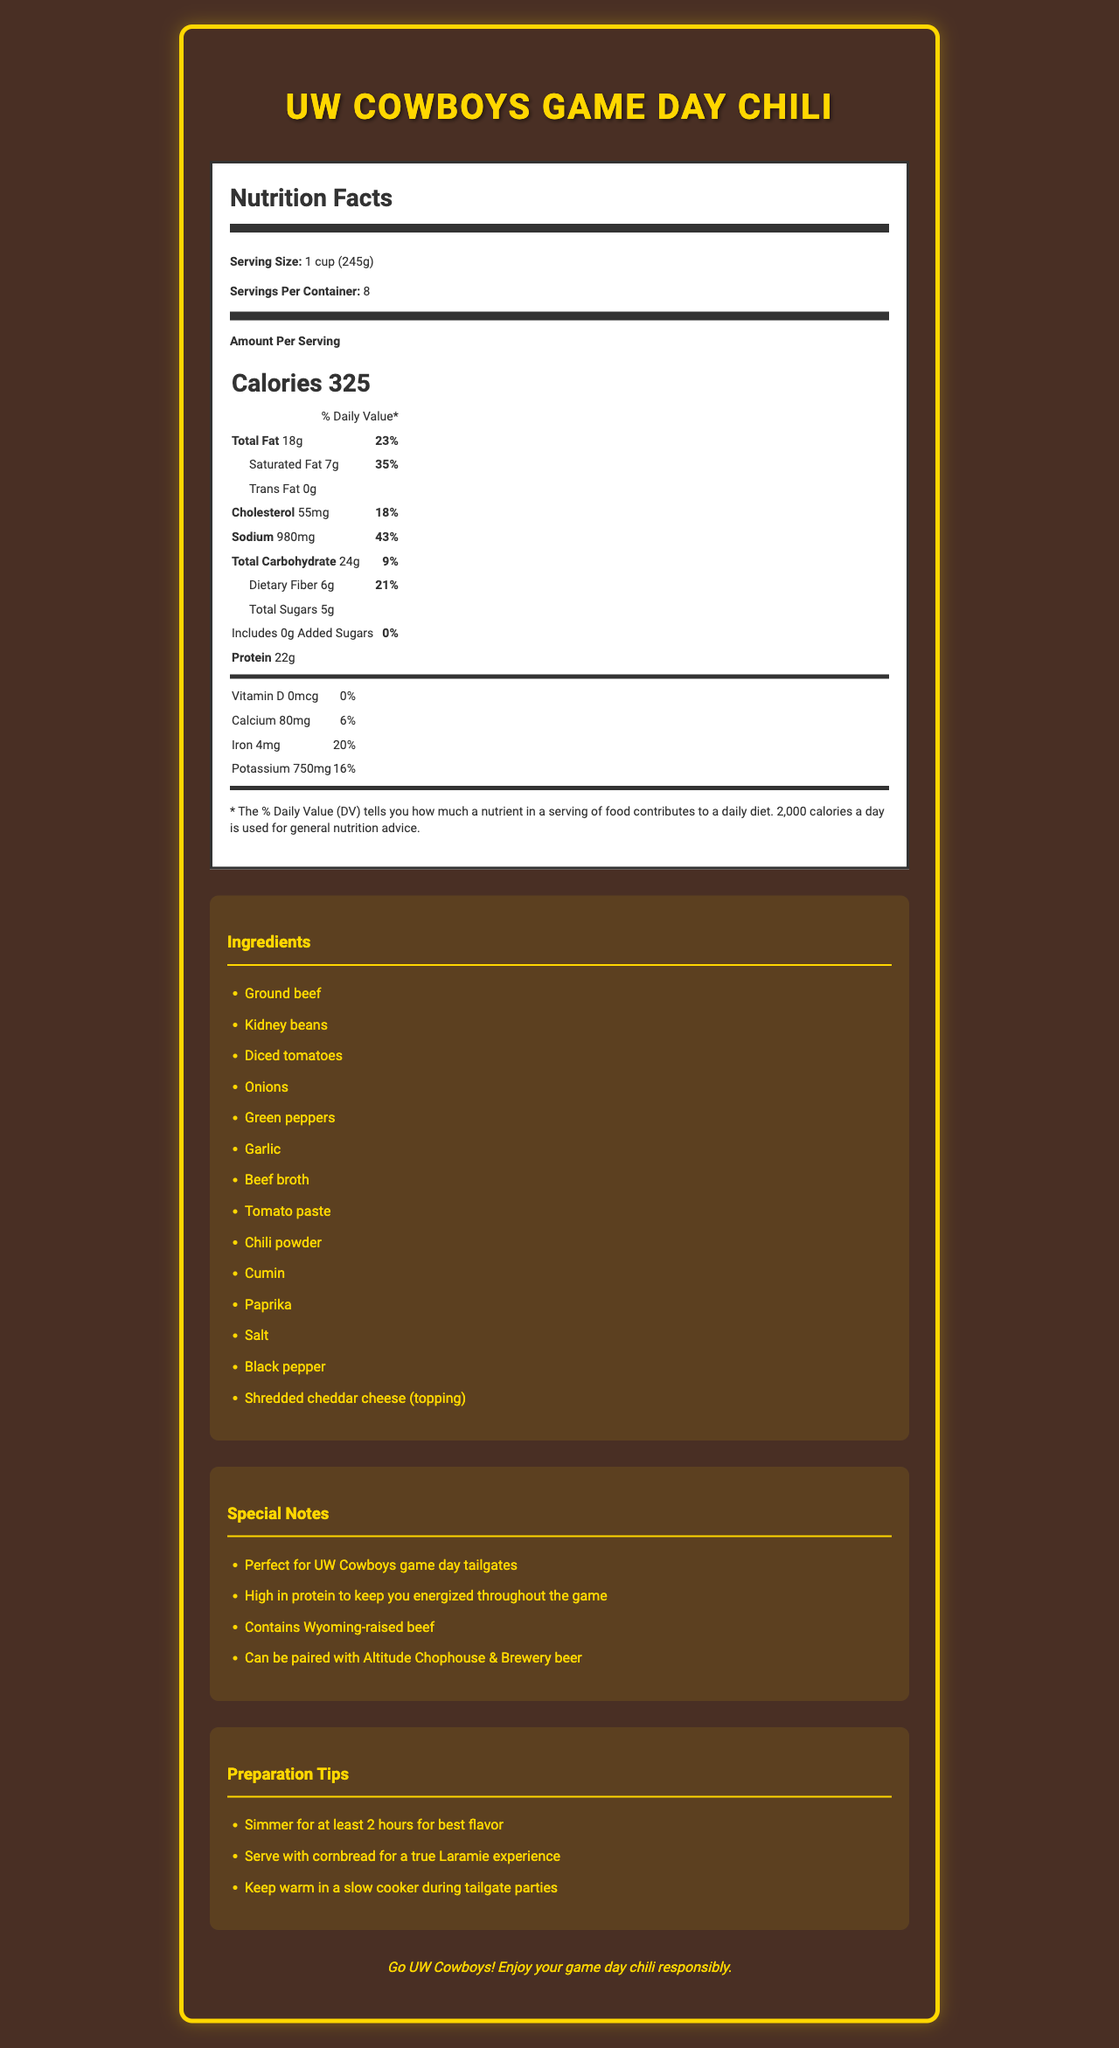what is the serving size for the chili? The serving size is specified right at the top of the nutrition label as "1 cup (245g)".
Answer: 1 cup (245g) how many calories are in a serving of this chili? The calories per serving are mentioned in bold as "Calories 325" on the nutrition label.
Answer: 325 what is the daily value percentage of potassium in a serving? This information is found in the table under potassium, which mentions "16%".
Answer: 16% how much protein is in each serving? The amount of protein per serving is listed as "22g" under the nutrition facts table.
Answer: 22g what allergen is listed for this chili recipe? The allergen information states "Milk" as the only listed allergen.
Answer: Milk what is the percentage of daily value for saturated fat in this chili? The daily value for saturated fat is mentioned as "35%" next to the saturated fat amount in the nutrition information.
Answer: 35% which of the following vitamins or minerals has the highest daily value percentage in the chili? A. Vitamin D B. Calcium C. Iron D. Potassium Iron has the highest daily value percentage at 20%, as shown in the nutrition facts.
Answer: C. Iron what type of beef is used in the chili according to the special notes? A. Grass-fed beef B. Wyoming-raised beef C. Organic beef D. Imported beef The special notes mention "Contains Wyoming-raised beef."
Answer: B. Wyoming-raised beef is the chili high in protein? The document highlights that the chili is "High in protein to keep you energized throughout the game," and it contains 22g of protein per serving.
Answer: Yes describe the main idea of the document. The document is structured to present comprehensive nutritional information and additional relevant details such as ingredients, special notes, and preparation tips to enhance the tailgate experience.
Answer: The document provides a detailed nutrition facts label for a UW Cowboys game day chili recipe, listing serving size, calorie content, macronutrients, vitamins, and minerals. Additionally, it includes a list of ingredients, special notes emphasizing the use of Wyoming-raised beef and game day suitability, and preparation tips for optimal flavor and experience. what is the cholesterol content per serving of the chili? The cholesterol content is listed as "55mg" on the nutrition facts label.
Answer: 55mg how many servings does the container of chili provide? The document specifies that there are 8 servings per container.
Answer: 8 what preparation tips are given for serving the chili at a tailgate party? The preparation tips section provides these three specific tips to enhance the chili's flavor and experience at a tailgate party.
Answer: Simmer for at least 2 hours for best flavor, Serve with cornbread for a true Laramie experience, Keep warm in a slow cooker during tailgate parties what is the ingredient listed as a topping for the chili? The ingredient list includes "Shredded cheddar cheese (topping)" as the topping for the chili.
Answer: Shredded cheddar cheese which nutrient does not have any added content in the chili? A. Sugar B. Sodium C. Potassium D. Protein The nutrition information specifies that the chili includes no added sugars.
Answer: A. Sugar what percentage of daily value for calcium does the chili provide? The nutrition facts indicate that the chili provides 6% of the daily value for calcium.
Answer: 6% what is the total carbohydrate content per serving? The total carbohydrate content is listed as "24g" in the nutrition information.
Answer: 24g how much sodium is in each serving of the chili? The sodium content per serving is given as "980mg" on the nutrition facts label.
Answer: 980mg what is the percentage of the daily value for dietary fiber in a serving? The daily value percentage for dietary fiber is indicated as "21%" in the nutrition information.
Answer: 21% what is the purpose of the document? A. To advertise a chili product B. To provide a grocery shopping list C. To offer nutrition information and preparation tips for a chili recipe D. To compare different chili recipes The document is designed to present the nutrition facts, ingredients, special notes, and preparation tips specifically for a game day chili recipe.
Answer: C. To offer nutrition information and preparation tips for a chili recipe can the amount of vitamin C in the chili be determined from this document? The document does not provide any information regarding the vitamin C content in the chili.
Answer: Cannot be determined 